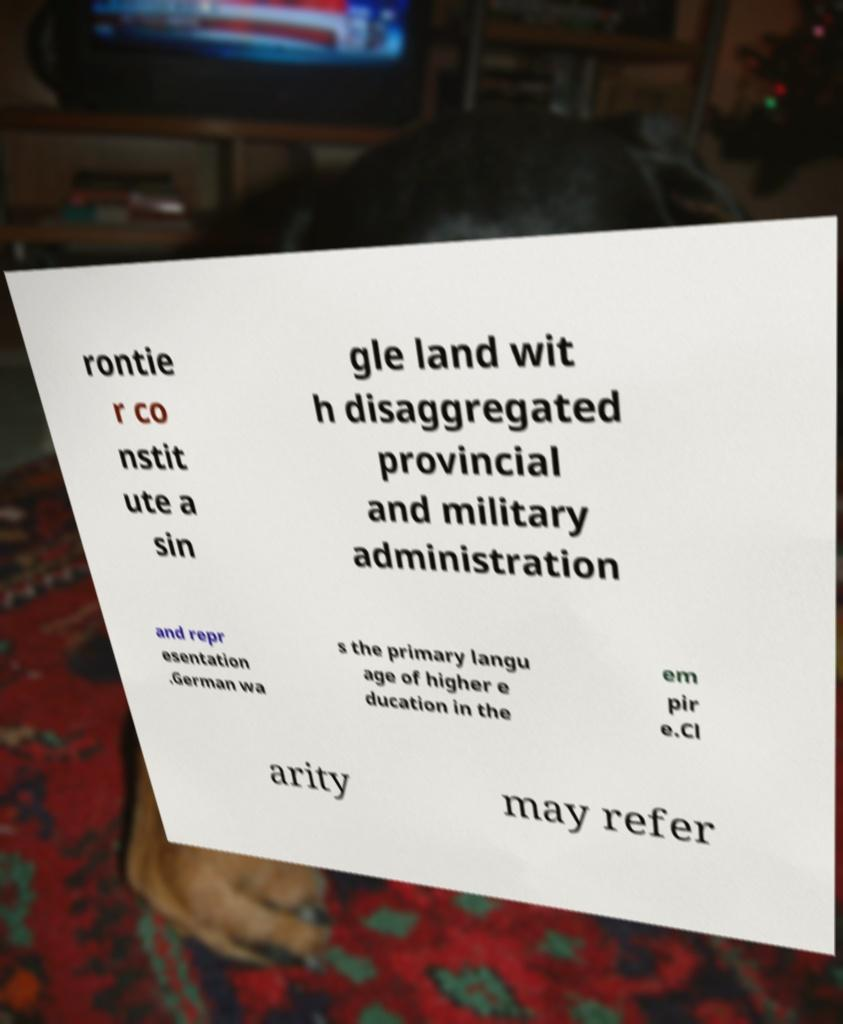Please identify and transcribe the text found in this image. rontie r co nstit ute a sin gle land wit h disaggregated provincial and military administration and repr esentation .German wa s the primary langu age of higher e ducation in the em pir e.Cl arity may refer 